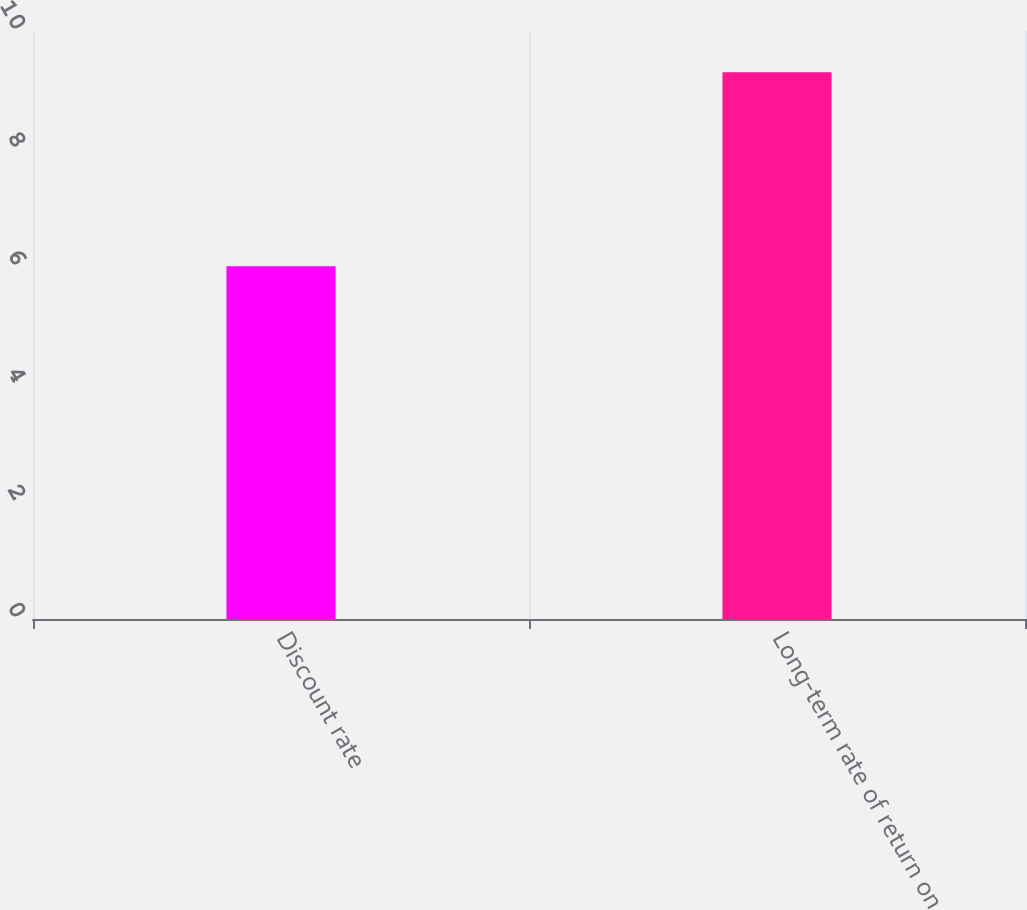Convert chart. <chart><loc_0><loc_0><loc_500><loc_500><bar_chart><fcel>Discount rate<fcel>Long-term rate of return on<nl><fcel>6<fcel>9.3<nl></chart> 